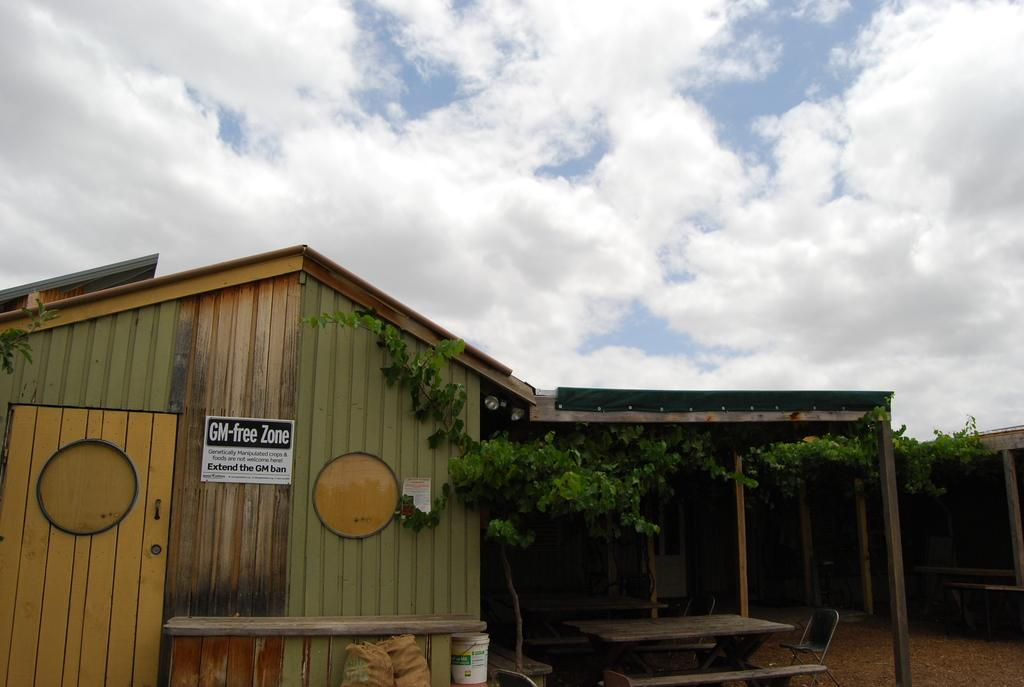What type of house is shown in the image? There is a wooden house in the image. Are there any unique features of the wooden house? Yes, the wooden house has stone pillars. What else can be seen in the image besides the wooden house? There is a plant in the image. What is visible at the top of the image? The sky is visible at the top of the image. How many straws are lying on the ground near the wooden house in the image? There are no straws visible in the image; it only shows a wooden house with stone pillars, a plant, and the sky. 